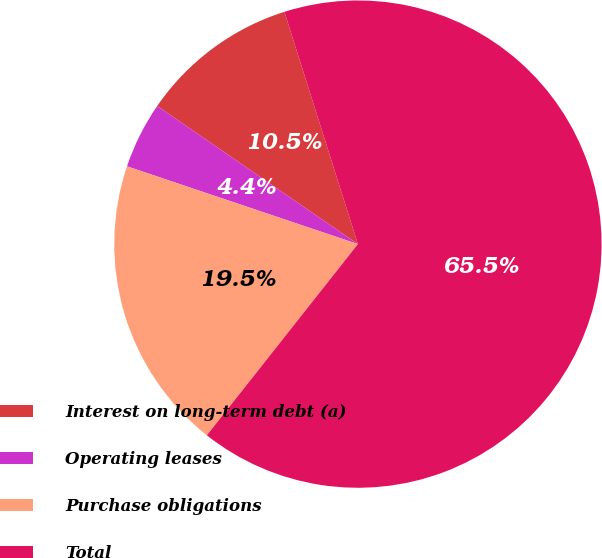<chart> <loc_0><loc_0><loc_500><loc_500><pie_chart><fcel>Interest on long-term debt (a)<fcel>Operating leases<fcel>Purchase obligations<fcel>Total<nl><fcel>10.53%<fcel>4.42%<fcel>19.53%<fcel>65.52%<nl></chart> 